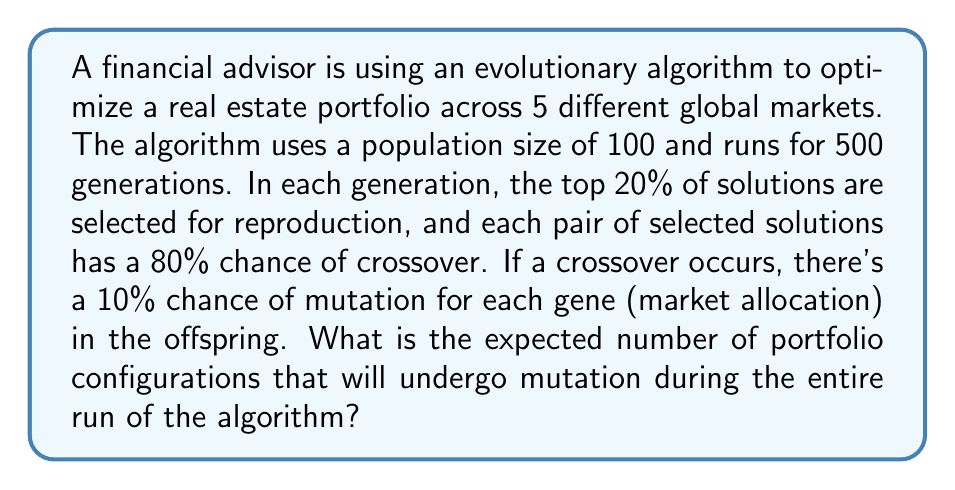What is the answer to this math problem? Let's break this down step-by-step:

1) First, we need to calculate the number of offspring produced in each generation:
   - 20% of 100 = 20 solutions selected for reproduction
   - These can form 10 pairs
   - Each pair has an 80% chance of crossover
   - Expected number of offspring per generation = $10 \times 0.80 = 8$

2) Now, let's calculate the number of genes (market allocations) in each offspring:
   - There are 5 markets, so each portfolio configuration has 5 genes

3) For each offspring, the probability of at least one mutation is:
   $P(\text{at least one mutation}) = 1 - P(\text{no mutations})$
   $= 1 - (0.90)^5 = 1 - 0.59049 = 0.40951$

4) The expected number of mutated offspring per generation is:
   $8 \times 0.40951 = 3.27608$

5) Over 500 generations, the expected number of mutated offspring is:
   $500 \times 3.27608 = 1638.04$

Therefore, the expected number of portfolio configurations that will undergo mutation during the entire run of the algorithm is approximately 1638.
Answer: 1638 